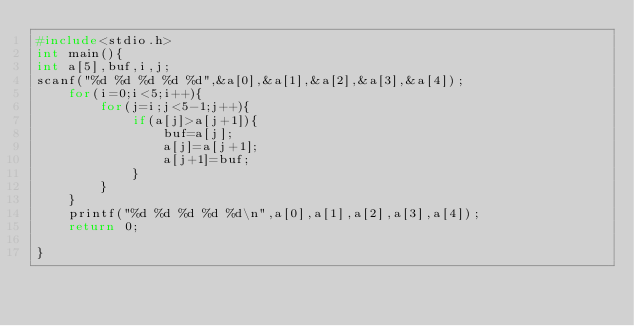<code> <loc_0><loc_0><loc_500><loc_500><_C_>#include<stdio.h>
int main(){
int a[5],buf,i,j;
scanf("%d %d %d %d %d",&a[0],&a[1],&a[2],&a[3],&a[4]);
	for(i=0;i<5;i++){
		for(j=i;j<5-1;j++){
			if(a[j]>a[j+1]){
				buf=a[j];
				a[j]=a[j+1];
				a[j+1]=buf;
			}
		}
	}
	printf("%d %d %d %d %d\n",a[0],a[1],a[2],a[3],a[4]);
	return 0;

}</code> 